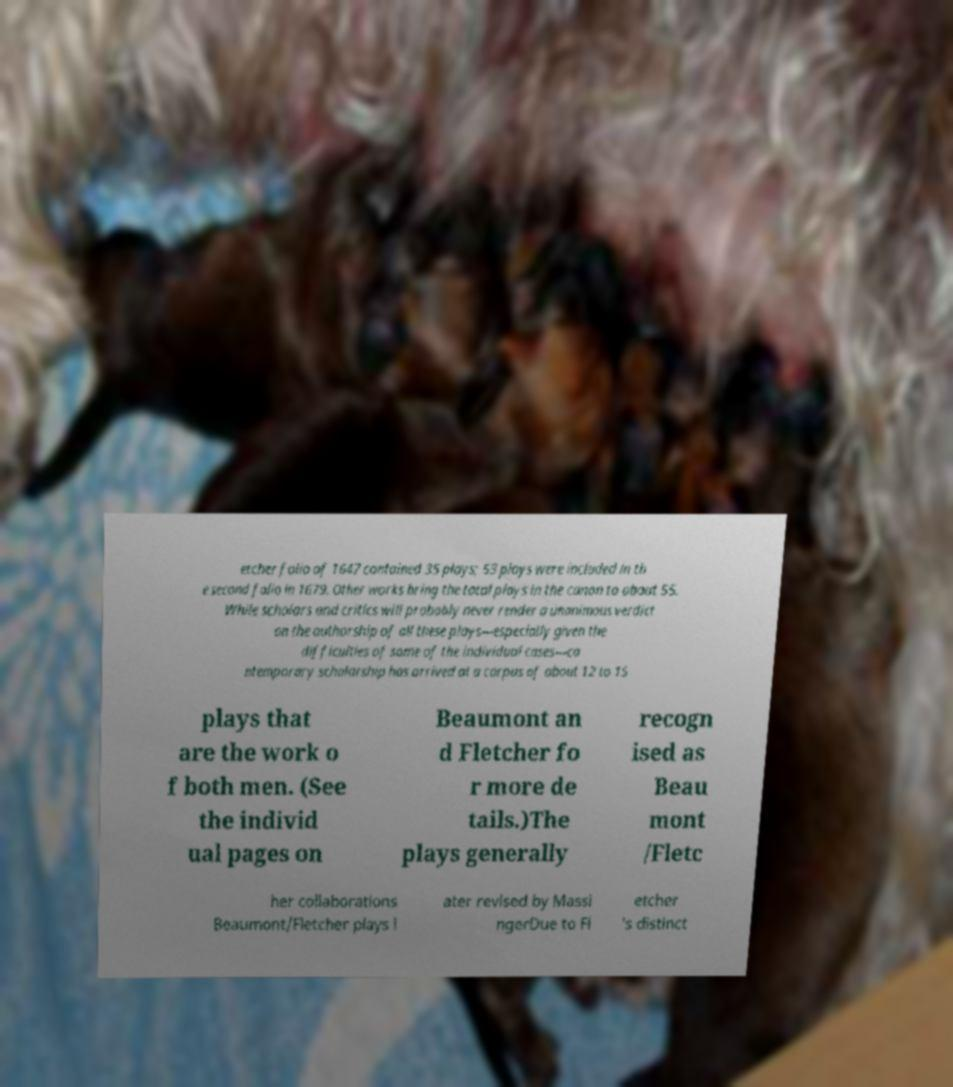There's text embedded in this image that I need extracted. Can you transcribe it verbatim? etcher folio of 1647 contained 35 plays; 53 plays were included in th e second folio in 1679. Other works bring the total plays in the canon to about 55. While scholars and critics will probably never render a unanimous verdict on the authorship of all these plays—especially given the difficulties of some of the individual cases—co ntemporary scholarship has arrived at a corpus of about 12 to 15 plays that are the work o f both men. (See the individ ual pages on Beaumont an d Fletcher fo r more de tails.)The plays generally recogn ised as Beau mont /Fletc her collaborations Beaumont/Fletcher plays l ater revised by Massi ngerDue to Fl etcher 's distinct 